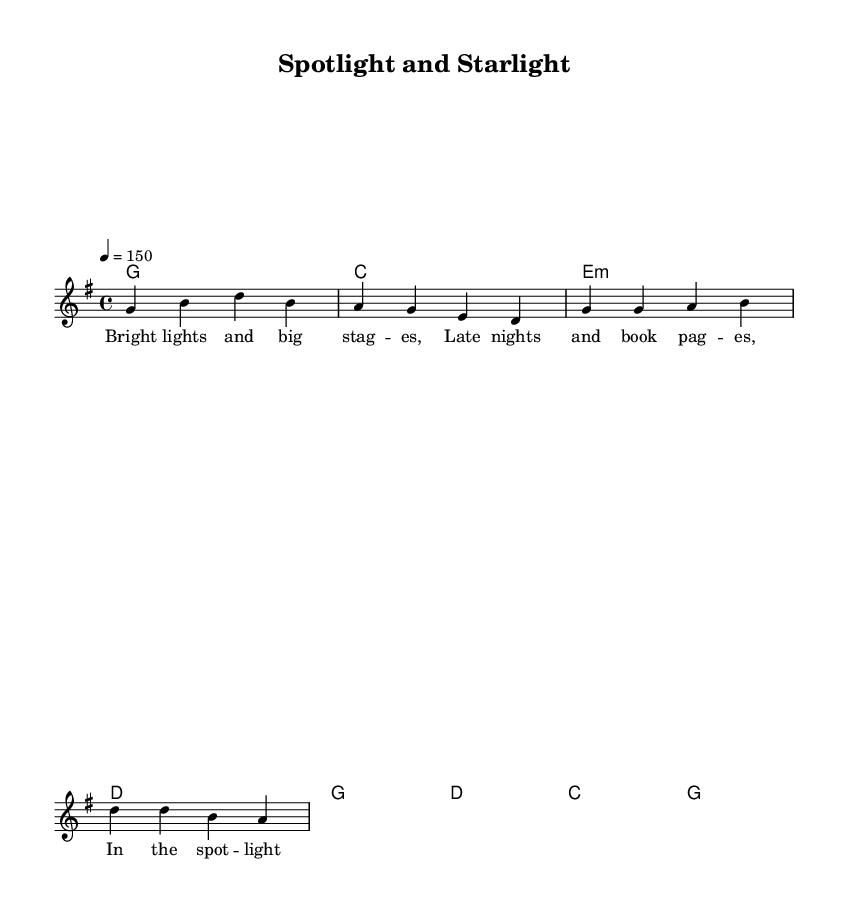What is the key signature of this music? The key signature is G major, indicated by one sharp (F#) at the beginning of the staff.
Answer: G major What is the time signature of this music? The time signature is 4/4, indicated at the beginning of the staff by the fraction with the top number 4 and the bottom number 4.
Answer: 4/4 What is the tempo marking for this music? The tempo marking is 150 beats per minute, noted by the text "4 = 150" above the staff.
Answer: 150 How many measures are in the verse? The verse section contains four measures, which can be counted directly from the staff.
Answer: 4 What is the last chord in the chorus? The last chord in the chorus is G major, which is indicated by the symbol "g" in the chord line of the sheet music.
Answer: G In the lyrics, what do the words "love's just out of sight" symbolize? The phrase suggests that despite fame and outward success, personal relationships may be elusive and difficult to maintain, illustrating the song's theme of balancing fame with personal connections.
Answer: Elusive What kind of musical genre does this piece represent? This piece is classified as Country Rock, which combines elements of country music with rock music stylings.
Answer: Country Rock 